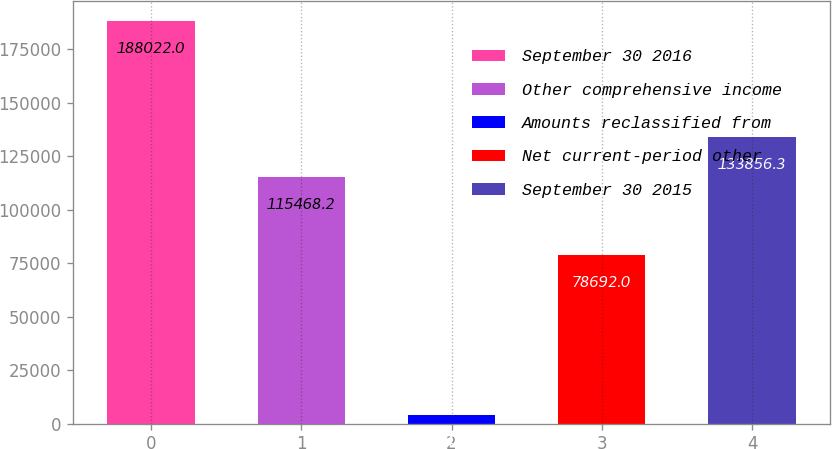Convert chart to OTSL. <chart><loc_0><loc_0><loc_500><loc_500><bar_chart><fcel>September 30 2016<fcel>Other comprehensive income<fcel>Amounts reclassified from<fcel>Net current-period other<fcel>September 30 2015<nl><fcel>188022<fcel>115468<fcel>4141<fcel>78692<fcel>133856<nl></chart> 